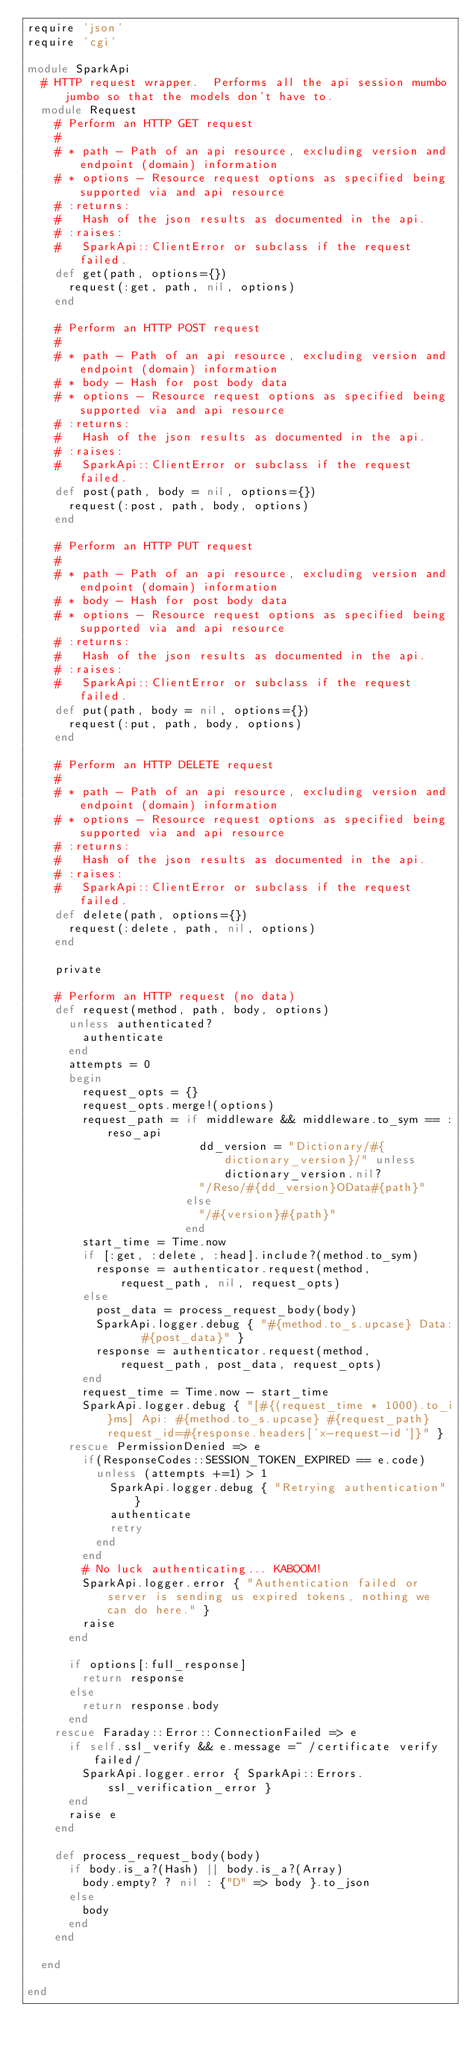Convert code to text. <code><loc_0><loc_0><loc_500><loc_500><_Ruby_>require 'json'
require 'cgi'

module SparkApi
  # HTTP request wrapper.  Performs all the api session mumbo jumbo so that the models don't have to.
  module Request
    # Perform an HTTP GET request
    # 
    # * path - Path of an api resource, excluding version and endpoint (domain) information
    # * options - Resource request options as specified being supported via and api resource
    # :returns:
    #   Hash of the json results as documented in the api.
    # :raises:
    #   SparkApi::ClientError or subclass if the request failed.
    def get(path, options={})
      request(:get, path, nil, options)
    end

    # Perform an HTTP POST request
    # 
    # * path - Path of an api resource, excluding version and endpoint (domain) information
    # * body - Hash for post body data
    # * options - Resource request options as specified being supported via and api resource
    # :returns:
    #   Hash of the json results as documented in the api.
    # :raises:
    #   SparkApi::ClientError or subclass if the request failed.
    def post(path, body = nil, options={})
      request(:post, path, body, options)
    end

    # Perform an HTTP PUT request
    # 
    # * path - Path of an api resource, excluding version and endpoint (domain) information
    # * body - Hash for post body data
    # * options - Resource request options as specified being supported via and api resource
    # :returns:
    #   Hash of the json results as documented in the api.
    # :raises:
    #   SparkApi::ClientError or subclass if the request failed.
    def put(path, body = nil, options={})
      request(:put, path, body, options)
    end

    # Perform an HTTP DELETE request
    # 
    # * path - Path of an api resource, excluding version and endpoint (domain) information
    # * options - Resource request options as specified being supported via and api resource
    # :returns:
    #   Hash of the json results as documented in the api.
    # :raises:
    #   SparkApi::ClientError or subclass if the request failed.
    def delete(path, options={})
      request(:delete, path, nil, options)
    end
    
    private

    # Perform an HTTP request (no data)
    def request(method, path, body, options)
      unless authenticated?
        authenticate
      end
      attempts = 0
      begin
        request_opts = {}
        request_opts.merge!(options)
        request_path = if middleware && middleware.to_sym == :reso_api
                         dd_version = "Dictionary/#{dictionary_version}/" unless dictionary_version.nil?
                         "/Reso/#{dd_version}OData#{path}"
                       else
                         "/#{version}#{path}"
                       end
        start_time = Time.now
        if [:get, :delete, :head].include?(method.to_sym)
          response = authenticator.request(method, request_path, nil, request_opts)
        else
          post_data = process_request_body(body)
          SparkApi.logger.debug { "#{method.to_s.upcase} Data:   #{post_data}" }
          response = authenticator.request(method, request_path, post_data, request_opts)
        end
        request_time = Time.now - start_time
        SparkApi.logger.debug { "[#{(request_time * 1000).to_i}ms] Api: #{method.to_s.upcase} #{request_path} request_id=#{response.headers['x-request-id']}" }
      rescue PermissionDenied => e
        if(ResponseCodes::SESSION_TOKEN_EXPIRED == e.code)
          unless (attempts +=1) > 1
            SparkApi.logger.debug { "Retrying authentication" }
            authenticate
            retry
          end
        end
        # No luck authenticating... KABOOM!
        SparkApi.logger.error { "Authentication failed or server is sending us expired tokens, nothing we can do here." }
        raise
      end

      if options[:full_response]
        return response
      else
        return response.body
      end
    rescue Faraday::Error::ConnectionFailed => e
      if self.ssl_verify && e.message =~ /certificate verify failed/
        SparkApi.logger.error { SparkApi::Errors.ssl_verification_error }
      end
      raise e
    end
    
    def process_request_body(body)
      if body.is_a?(Hash) || body.is_a?(Array)
        body.empty? ? nil : {"D" => body }.to_json
      else
        body
      end
    end
    
  end
 
end
</code> 